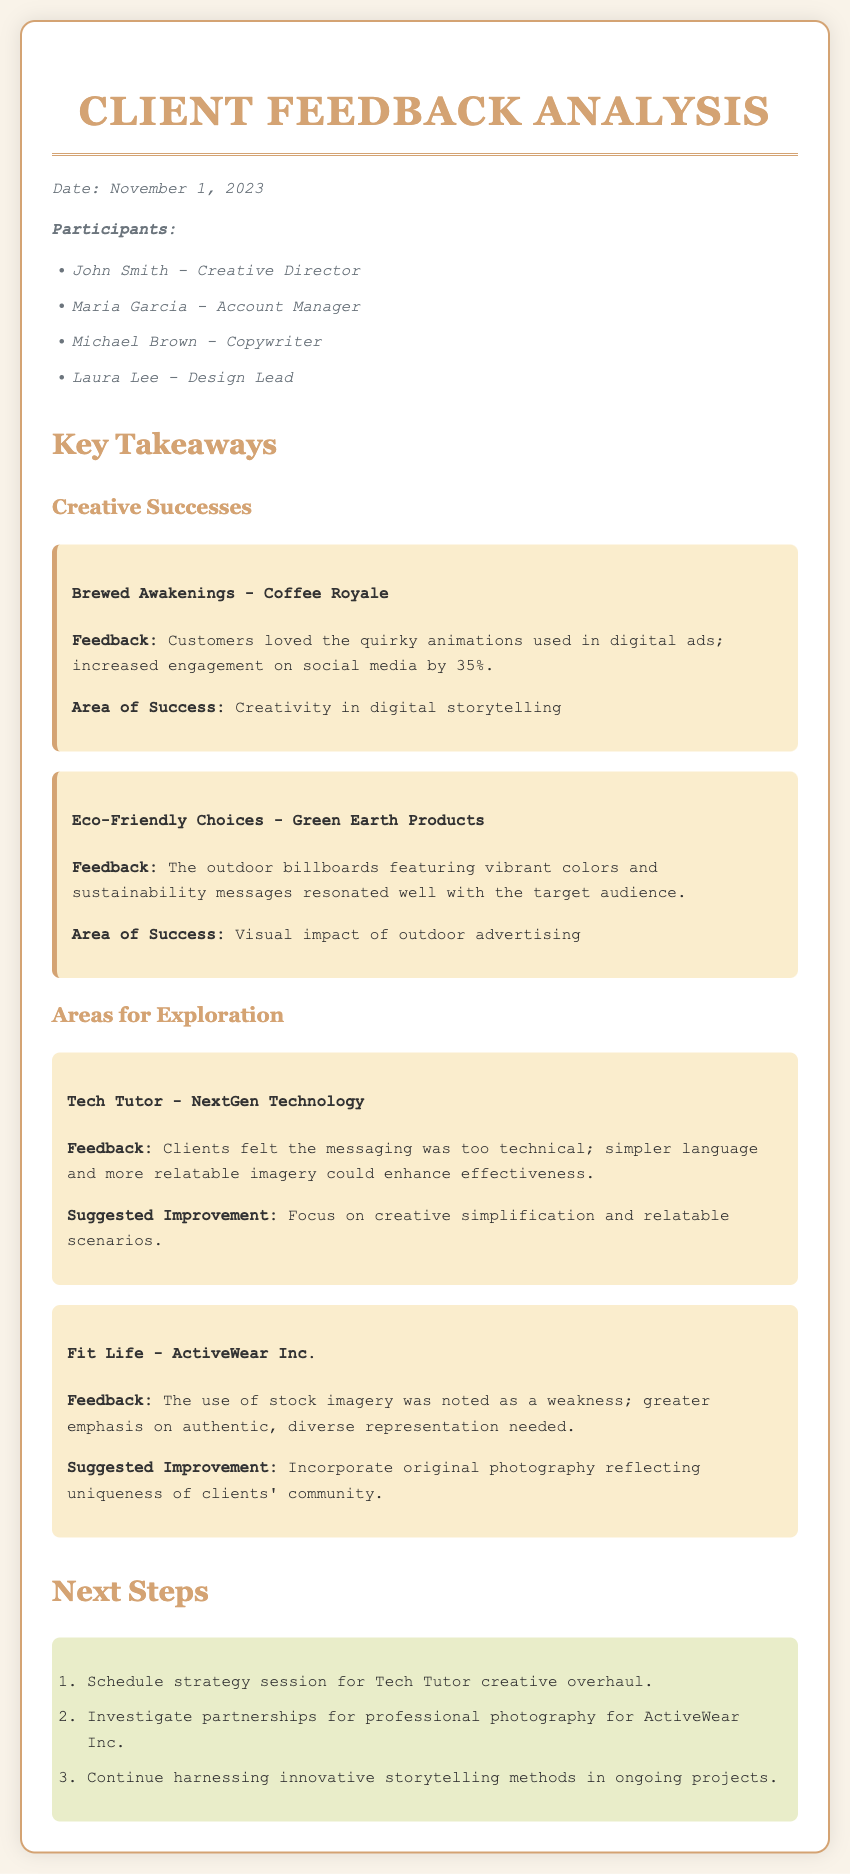What was the date of the meeting? The meeting date is explicitly stated at the beginning of the minutes.
Answer: November 1, 2023 Who was the Design Lead that participated in the meeting? The participants are listed, including their roles.
Answer: Laura Lee What was the increase in engagement on social media for Brewed Awakenings? The feedback section specifies the engagement increase resulting from creative efforts.
Answer: 35% What was identified as a weakness in the Fit Life campaign? The areas for exploration detail specific feedback on weaknesses in campaigns.
Answer: Use of stock imagery What is the suggested improvement for the Tech Tutor campaign? The minutes provide a suggested improvement for underperforming campaigns.
Answer: Creative simplification and relatable scenarios How many next steps were outlined in the meeting minutes? The next steps section lists specific actions to be taken, which can be counted.
Answer: 3 